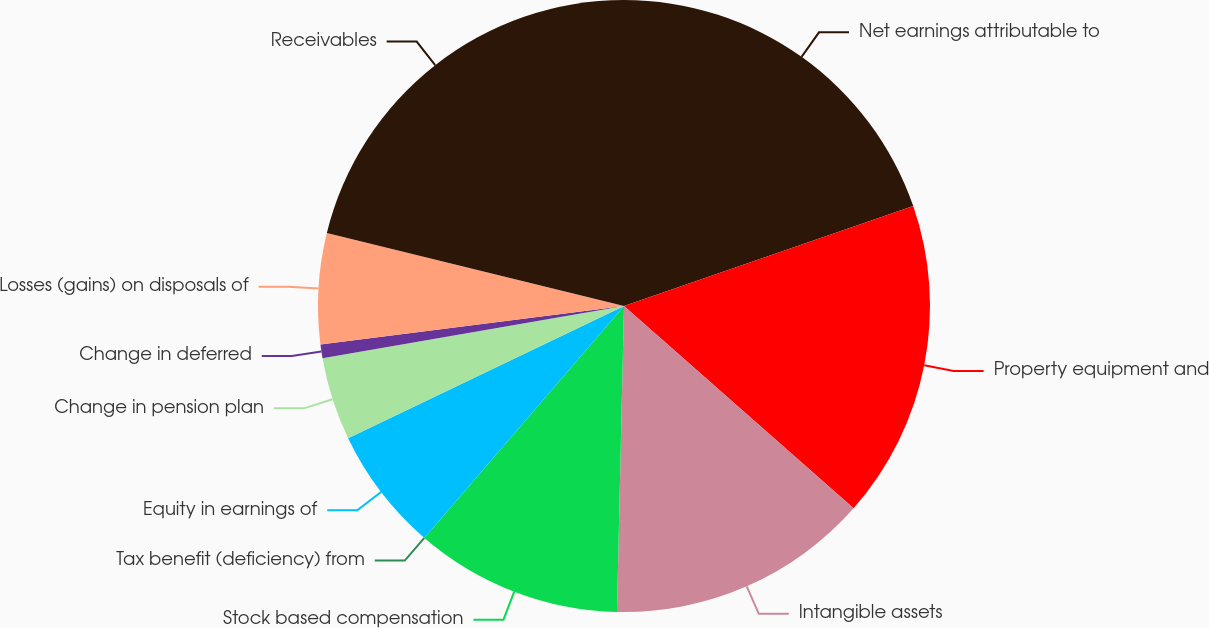<chart> <loc_0><loc_0><loc_500><loc_500><pie_chart><fcel>Net earnings attributable to<fcel>Property equipment and<fcel>Intangible assets<fcel>Stock based compensation<fcel>Tax benefit (deficiency) from<fcel>Equity in earnings of<fcel>Change in pension plan<fcel>Change in deferred<fcel>Losses (gains) on disposals of<fcel>Receivables<nl><fcel>19.71%<fcel>16.79%<fcel>13.87%<fcel>10.95%<fcel>0.0%<fcel>6.57%<fcel>4.38%<fcel>0.73%<fcel>5.84%<fcel>21.17%<nl></chart> 